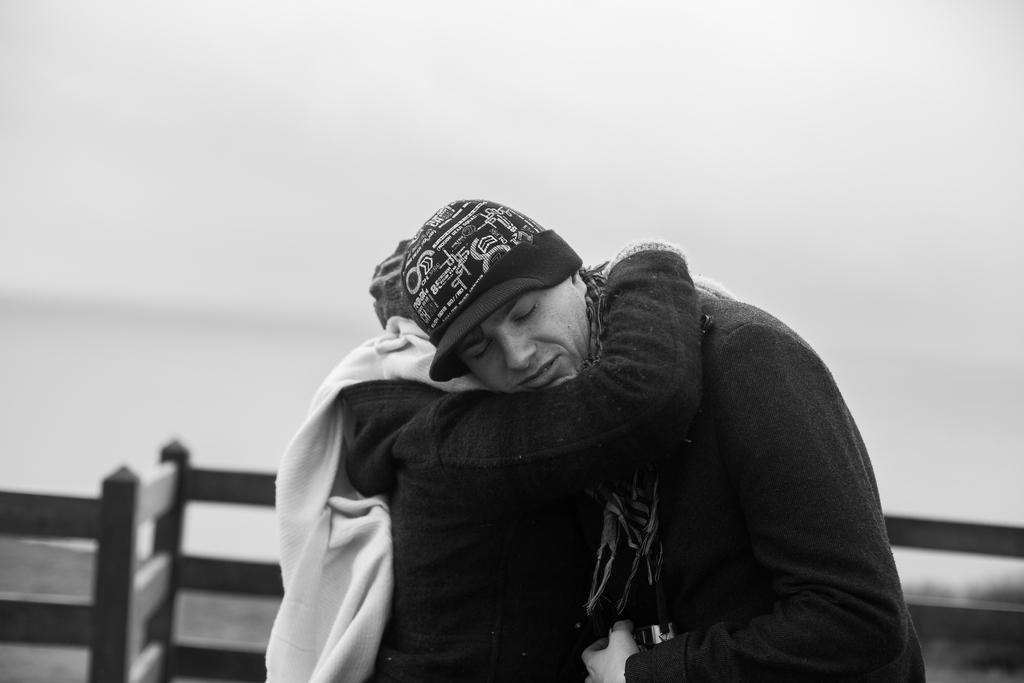How many people are in the center of the image? There are two members in the middle of the image. What can be seen behind the two members? There is a railing visible behind the two members. What is the color scheme of the image? The image is black and white. What type of plastic part can be seen on the swing in the image? There is no swing or plastic part present in the image; it is a black and white image featuring two members and a railing. 